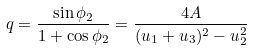Convert formula to latex. <formula><loc_0><loc_0><loc_500><loc_500>q = \frac { \sin \phi _ { 2 } } { 1 + \cos \phi _ { 2 } } = \frac { 4 A } { ( u _ { 1 } + u _ { 3 } ) ^ { 2 } - u _ { 2 } ^ { 2 } }</formula> 